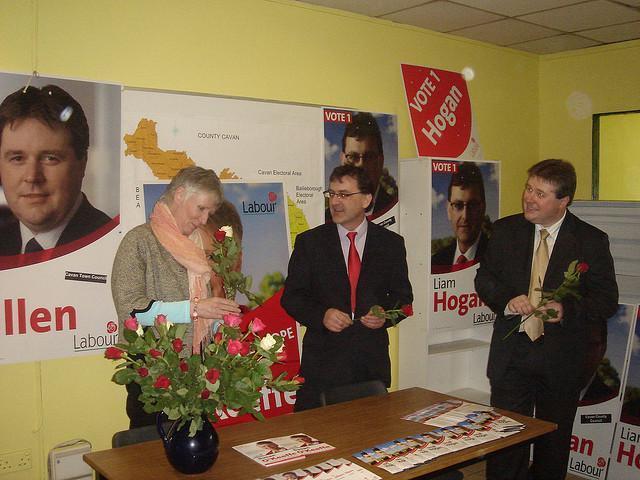How many people are in the picture?
Give a very brief answer. 5. 